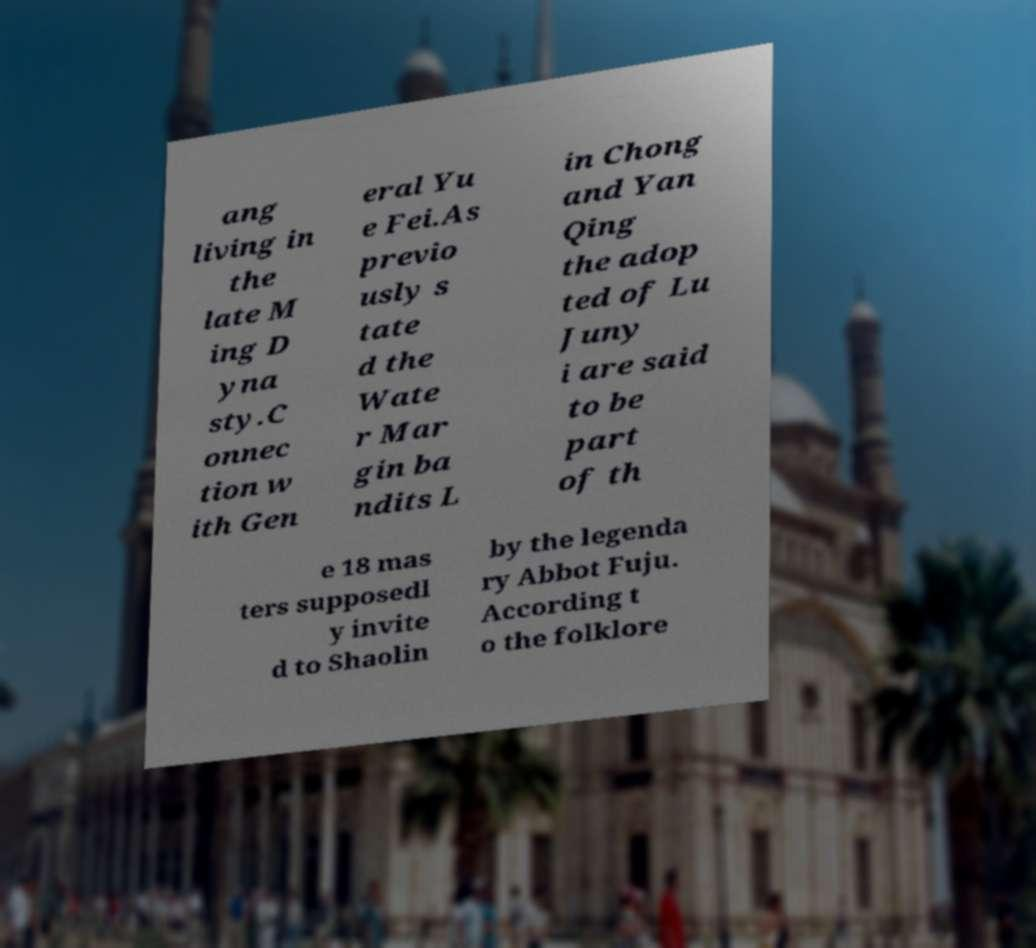Can you read and provide the text displayed in the image?This photo seems to have some interesting text. Can you extract and type it out for me? ang living in the late M ing D yna sty.C onnec tion w ith Gen eral Yu e Fei.As previo usly s tate d the Wate r Mar gin ba ndits L in Chong and Yan Qing the adop ted of Lu Juny i are said to be part of th e 18 mas ters supposedl y invite d to Shaolin by the legenda ry Abbot Fuju. According t o the folklore 